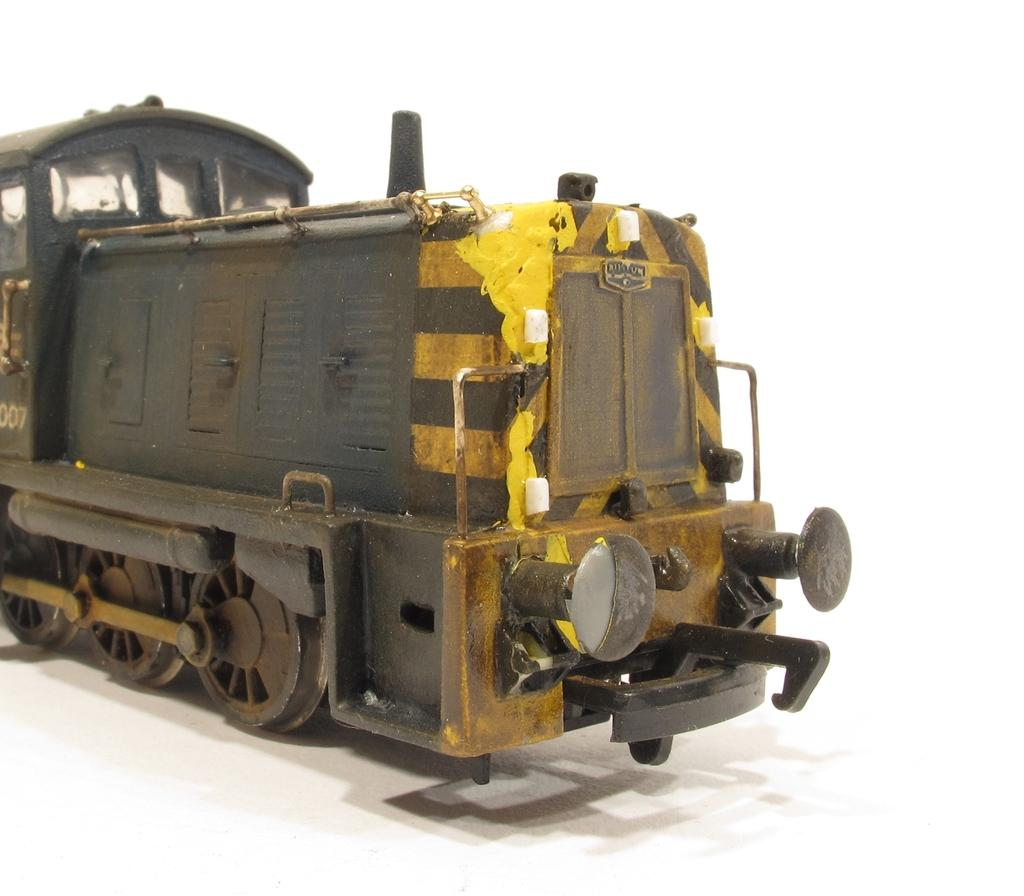What is the main subject of the image? The main subject of the image is the engine of a train. What colors are used to paint the engine? The engine is in black and yellow color, with the bottom part being white. What color is the background of the image? The background of the image is white in color. What type of church can be seen in the background of the image? There is no church present in the image; it only shows the train engine and the white background. 